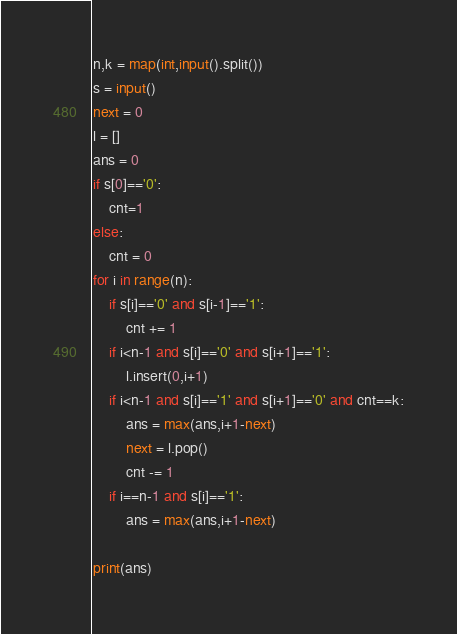<code> <loc_0><loc_0><loc_500><loc_500><_Python_>n,k = map(int,input().split())
s = input()
next = 0
l = []
ans = 0
if s[0]=='0':
    cnt=1
else:
    cnt = 0
for i in range(n):
    if s[i]=='0' and s[i-1]=='1':
        cnt += 1
    if i<n-1 and s[i]=='0' and s[i+1]=='1':
        l.insert(0,i+1)
    if i<n-1 and s[i]=='1' and s[i+1]=='0' and cnt==k:
        ans = max(ans,i+1-next)
        next = l.pop()
        cnt -= 1
    if i==n-1 and s[i]=='1':
        ans = max(ans,i+1-next)

print(ans)</code> 